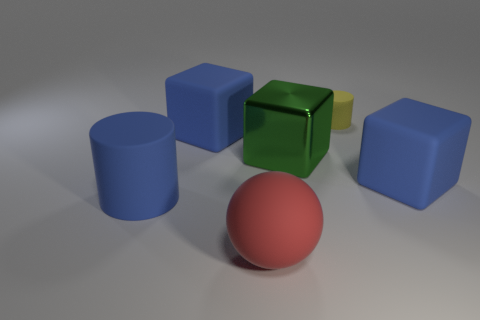How many other things are the same size as the yellow rubber cylinder?
Your response must be concise. 0. What number of green objects are either small matte cylinders or matte objects?
Provide a short and direct response. 0. What is the large blue cube behind the large green metal object made of?
Your answer should be compact. Rubber. Is the number of large blue blocks greater than the number of large brown rubber objects?
Give a very brief answer. Yes. There is a blue matte thing that is to the right of the tiny cylinder; does it have the same shape as the yellow matte object?
Your response must be concise. No. What number of large rubber things are both to the left of the tiny cylinder and on the right side of the big red sphere?
Your answer should be very brief. 0. What number of other large things are the same shape as the green object?
Give a very brief answer. 2. What color is the large rubber thing that is on the right side of the matte cylinder to the right of the rubber sphere?
Your answer should be very brief. Blue. There is a big green thing; does it have the same shape as the large rubber thing on the right side of the big red matte sphere?
Your answer should be very brief. Yes. What material is the cylinder that is behind the rubber cube that is left of the blue matte cube that is right of the big red rubber sphere made of?
Offer a very short reply. Rubber. 